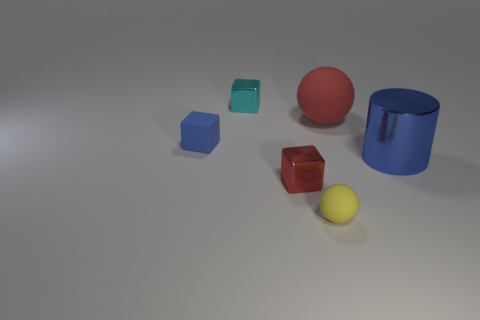There is a shiny block in front of the small cyan metallic thing; what number of cyan blocks are in front of it?
Make the answer very short. 0. Are there any large matte things to the left of the small yellow rubber object?
Make the answer very short. No. Is the shape of the blue thing behind the shiny cylinder the same as  the big shiny thing?
Offer a very short reply. No. There is a small object that is the same color as the big cylinder; what is its material?
Offer a very short reply. Rubber. What number of small blocks are the same color as the cylinder?
Keep it short and to the point. 1. What shape is the small cyan thing that is behind the metal cube in front of the large blue metallic cylinder?
Offer a very short reply. Cube. Is there a big brown metallic object that has the same shape as the tiny yellow rubber thing?
Make the answer very short. No. There is a metallic cylinder; is its color the same as the matte ball behind the yellow object?
Provide a short and direct response. No. What is the size of the rubber cube that is the same color as the large metallic cylinder?
Give a very brief answer. Small. Are there any green shiny spheres of the same size as the blue cylinder?
Keep it short and to the point. No. 